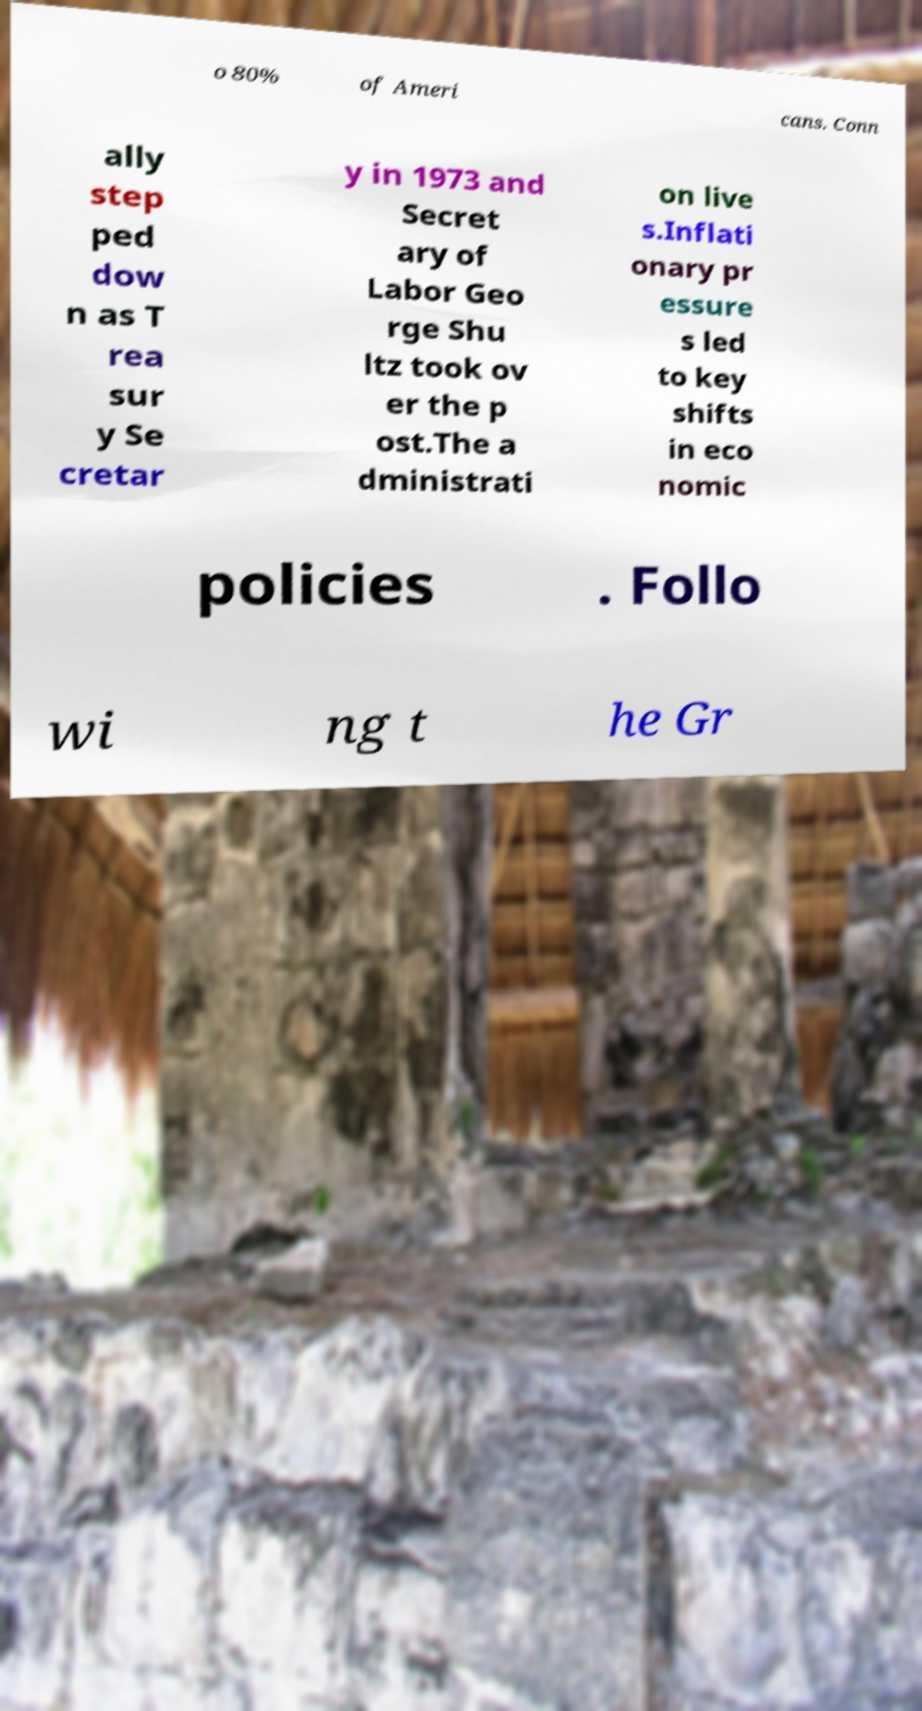Please read and relay the text visible in this image. What does it say? o 80% of Ameri cans. Conn ally step ped dow n as T rea sur y Se cretar y in 1973 and Secret ary of Labor Geo rge Shu ltz took ov er the p ost.The a dministrati on live s.Inflati onary pr essure s led to key shifts in eco nomic policies . Follo wi ng t he Gr 